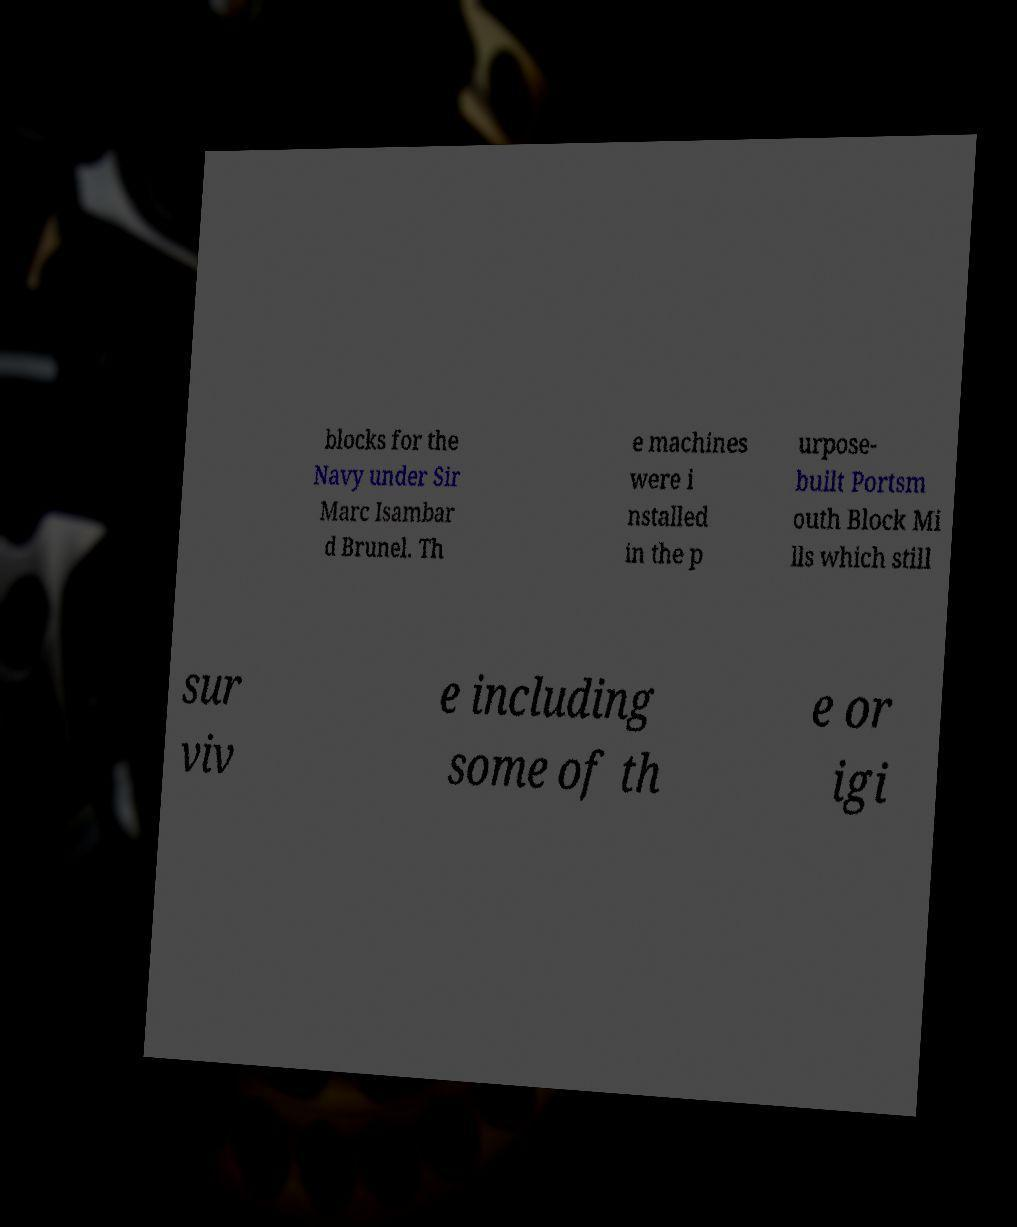For documentation purposes, I need the text within this image transcribed. Could you provide that? blocks for the Navy under Sir Marc Isambar d Brunel. Th e machines were i nstalled in the p urpose- built Portsm outh Block Mi lls which still sur viv e including some of th e or igi 